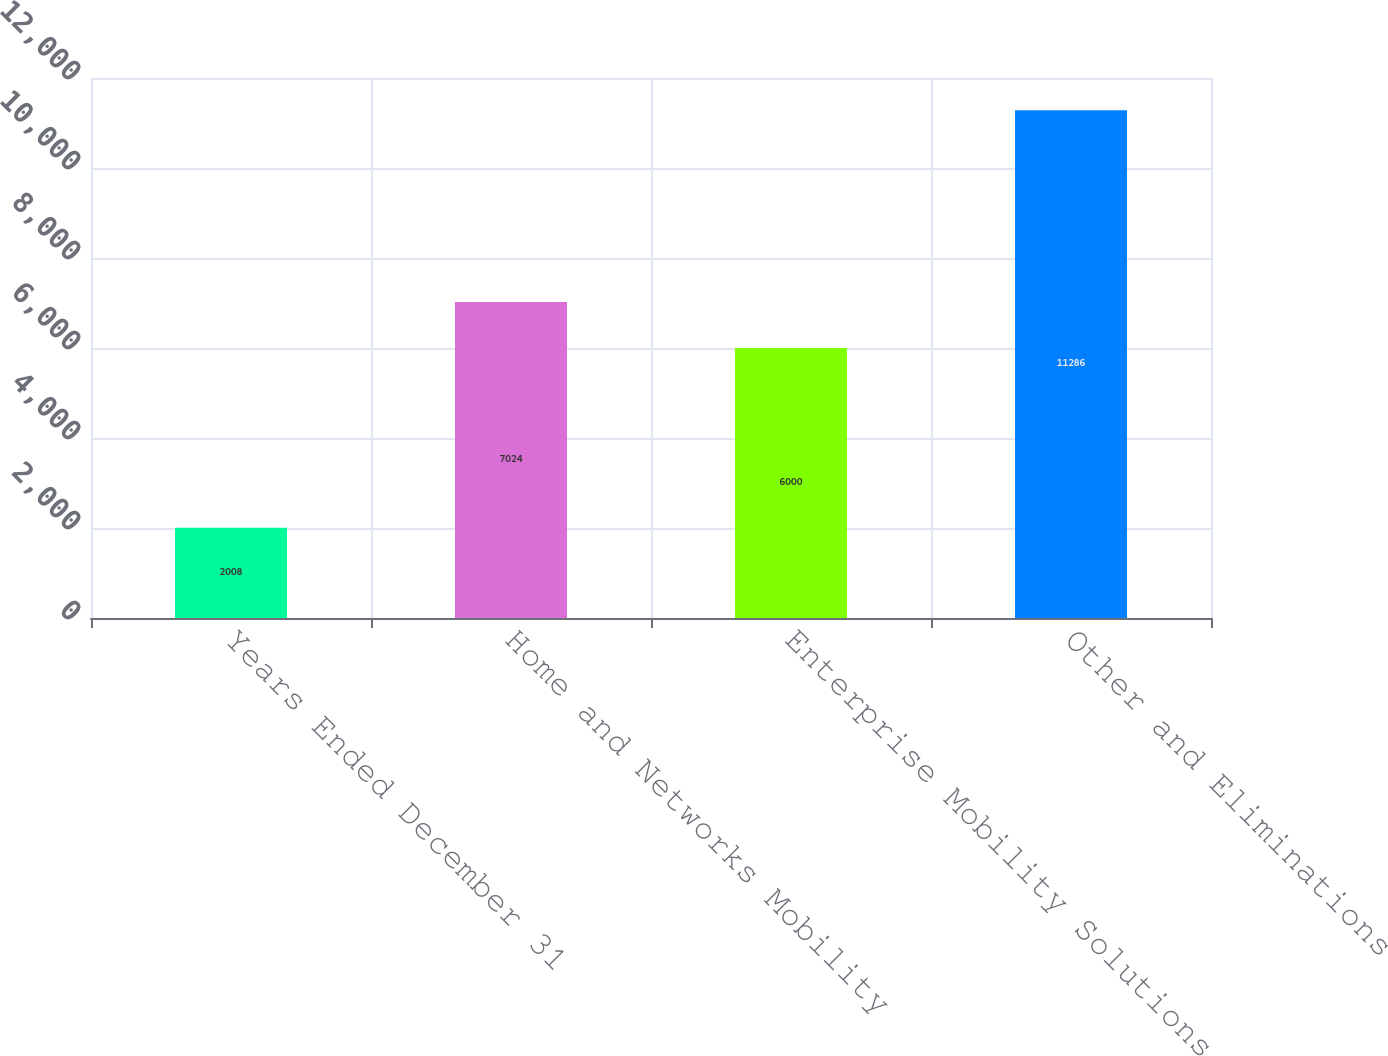Convert chart. <chart><loc_0><loc_0><loc_500><loc_500><bar_chart><fcel>Years Ended December 31<fcel>Home and Networks Mobility<fcel>Enterprise Mobility Solutions<fcel>Other and Eliminations<nl><fcel>2008<fcel>7024<fcel>6000<fcel>11286<nl></chart> 